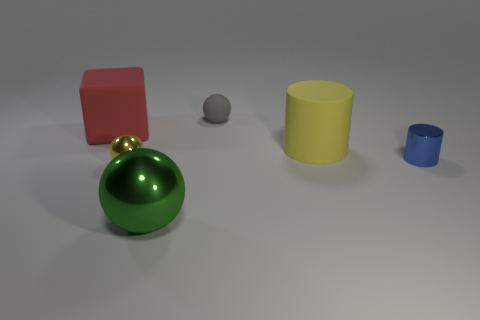Subtract all metallic balls. How many balls are left? 1 Subtract all blue cylinders. How many cylinders are left? 1 Subtract all cylinders. How many objects are left? 4 Add 1 large yellow cylinders. How many objects exist? 7 Subtract 2 cylinders. How many cylinders are left? 0 Subtract all small metallic balls. Subtract all big yellow objects. How many objects are left? 4 Add 4 gray rubber spheres. How many gray rubber spheres are left? 5 Add 6 brown matte balls. How many brown matte balls exist? 6 Subtract 1 red blocks. How many objects are left? 5 Subtract all blue cylinders. Subtract all red cubes. How many cylinders are left? 1 